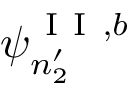Convert formula to latex. <formula><loc_0><loc_0><loc_500><loc_500>\psi _ { n _ { 2 } ^ { \prime } } ^ { I I , b }</formula> 